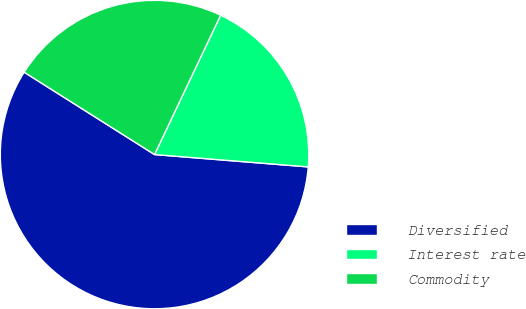<chart> <loc_0><loc_0><loc_500><loc_500><pie_chart><fcel>Diversified<fcel>Interest rate<fcel>Commodity<nl><fcel>57.69%<fcel>19.23%<fcel>23.08%<nl></chart> 